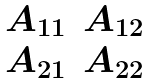<formula> <loc_0><loc_0><loc_500><loc_500>\begin{matrix} A _ { 1 1 } & A _ { 1 2 } \\ A _ { 2 1 } & A _ { 2 2 } \end{matrix}</formula> 